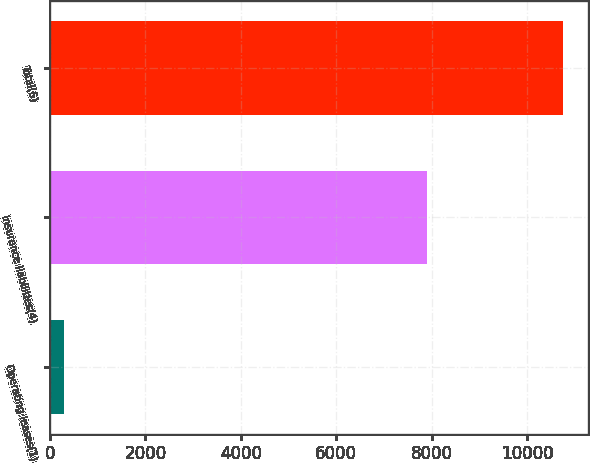Convert chart to OTSL. <chart><loc_0><loc_0><loc_500><loc_500><bar_chart><fcel>Operating leases(1)<fcel>Insurance liabilities(4)<fcel>Total(6)<nl><fcel>300<fcel>7909<fcel>10747<nl></chart> 